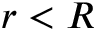<formula> <loc_0><loc_0><loc_500><loc_500>r < R</formula> 